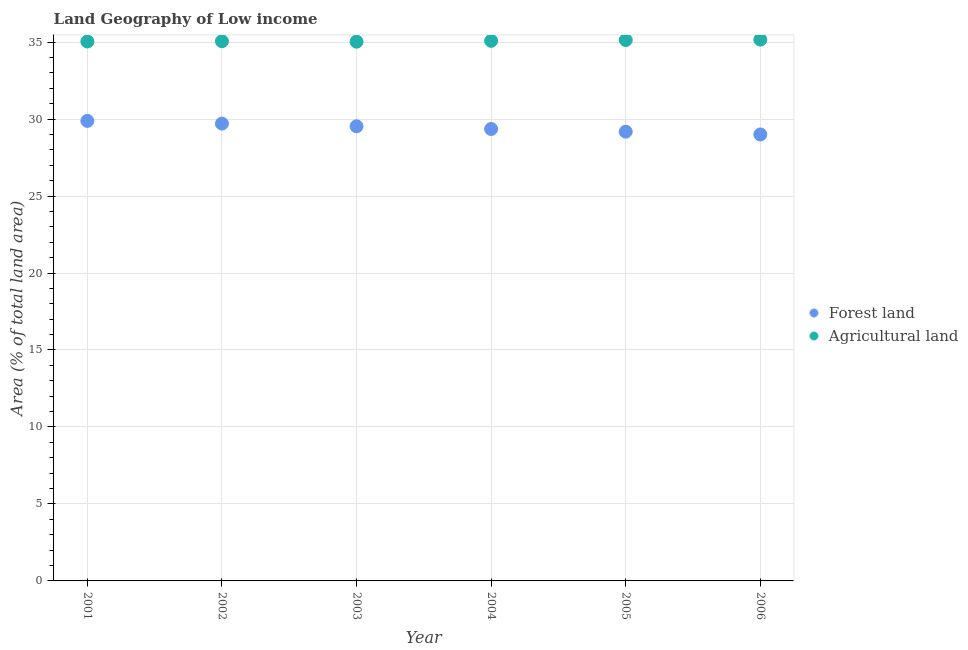Is the number of dotlines equal to the number of legend labels?
Provide a succinct answer. Yes. What is the percentage of land area under forests in 2001?
Ensure brevity in your answer.  29.88. Across all years, what is the maximum percentage of land area under forests?
Ensure brevity in your answer.  29.88. Across all years, what is the minimum percentage of land area under agriculture?
Keep it short and to the point. 35.03. In which year was the percentage of land area under agriculture minimum?
Give a very brief answer. 2003. What is the total percentage of land area under agriculture in the graph?
Keep it short and to the point. 210.5. What is the difference between the percentage of land area under forests in 2005 and that in 2006?
Give a very brief answer. 0.18. What is the difference between the percentage of land area under agriculture in 2001 and the percentage of land area under forests in 2004?
Your response must be concise. 5.68. What is the average percentage of land area under agriculture per year?
Make the answer very short. 35.08. In the year 2006, what is the difference between the percentage of land area under forests and percentage of land area under agriculture?
Give a very brief answer. -6.16. What is the ratio of the percentage of land area under agriculture in 2002 to that in 2006?
Give a very brief answer. 1. What is the difference between the highest and the second highest percentage of land area under forests?
Provide a short and direct response. 0.18. What is the difference between the highest and the lowest percentage of land area under agriculture?
Your response must be concise. 0.13. Does the percentage of land area under agriculture monotonically increase over the years?
Provide a succinct answer. No. Is the percentage of land area under forests strictly less than the percentage of land area under agriculture over the years?
Your answer should be compact. Yes. How many years are there in the graph?
Your response must be concise. 6. Are the values on the major ticks of Y-axis written in scientific E-notation?
Your answer should be very brief. No. Does the graph contain any zero values?
Your answer should be very brief. No. Does the graph contain grids?
Give a very brief answer. Yes. Where does the legend appear in the graph?
Keep it short and to the point. Center right. How many legend labels are there?
Provide a succinct answer. 2. How are the legend labels stacked?
Ensure brevity in your answer.  Vertical. What is the title of the graph?
Offer a terse response. Land Geography of Low income. What is the label or title of the X-axis?
Offer a terse response. Year. What is the label or title of the Y-axis?
Make the answer very short. Area (% of total land area). What is the Area (% of total land area) of Forest land in 2001?
Ensure brevity in your answer.  29.88. What is the Area (% of total land area) in Agricultural land in 2001?
Your answer should be compact. 35.04. What is the Area (% of total land area) in Forest land in 2002?
Ensure brevity in your answer.  29.71. What is the Area (% of total land area) of Agricultural land in 2002?
Make the answer very short. 35.06. What is the Area (% of total land area) in Forest land in 2003?
Provide a succinct answer. 29.53. What is the Area (% of total land area) of Agricultural land in 2003?
Ensure brevity in your answer.  35.03. What is the Area (% of total land area) of Forest land in 2004?
Your answer should be compact. 29.35. What is the Area (% of total land area) in Agricultural land in 2004?
Offer a terse response. 35.08. What is the Area (% of total land area) in Forest land in 2005?
Ensure brevity in your answer.  29.18. What is the Area (% of total land area) of Agricultural land in 2005?
Provide a short and direct response. 35.13. What is the Area (% of total land area) in Forest land in 2006?
Your answer should be very brief. 29. What is the Area (% of total land area) in Agricultural land in 2006?
Provide a short and direct response. 35.16. Across all years, what is the maximum Area (% of total land area) in Forest land?
Make the answer very short. 29.88. Across all years, what is the maximum Area (% of total land area) in Agricultural land?
Offer a terse response. 35.16. Across all years, what is the minimum Area (% of total land area) of Forest land?
Give a very brief answer. 29. Across all years, what is the minimum Area (% of total land area) in Agricultural land?
Ensure brevity in your answer.  35.03. What is the total Area (% of total land area) in Forest land in the graph?
Your answer should be compact. 176.65. What is the total Area (% of total land area) of Agricultural land in the graph?
Your answer should be compact. 210.5. What is the difference between the Area (% of total land area) of Forest land in 2001 and that in 2002?
Offer a terse response. 0.18. What is the difference between the Area (% of total land area) in Agricultural land in 2001 and that in 2002?
Give a very brief answer. -0.02. What is the difference between the Area (% of total land area) in Forest land in 2001 and that in 2003?
Give a very brief answer. 0.35. What is the difference between the Area (% of total land area) of Agricultural land in 2001 and that in 2003?
Your response must be concise. 0.01. What is the difference between the Area (% of total land area) of Forest land in 2001 and that in 2004?
Your answer should be compact. 0.53. What is the difference between the Area (% of total land area) of Agricultural land in 2001 and that in 2004?
Your answer should be compact. -0.04. What is the difference between the Area (% of total land area) in Forest land in 2001 and that in 2005?
Make the answer very short. 0.7. What is the difference between the Area (% of total land area) in Agricultural land in 2001 and that in 2005?
Your answer should be compact. -0.09. What is the difference between the Area (% of total land area) in Forest land in 2001 and that in 2006?
Ensure brevity in your answer.  0.88. What is the difference between the Area (% of total land area) of Agricultural land in 2001 and that in 2006?
Keep it short and to the point. -0.12. What is the difference between the Area (% of total land area) of Forest land in 2002 and that in 2003?
Keep it short and to the point. 0.18. What is the difference between the Area (% of total land area) in Agricultural land in 2002 and that in 2003?
Offer a terse response. 0.03. What is the difference between the Area (% of total land area) of Forest land in 2002 and that in 2004?
Ensure brevity in your answer.  0.35. What is the difference between the Area (% of total land area) in Agricultural land in 2002 and that in 2004?
Offer a very short reply. -0.02. What is the difference between the Area (% of total land area) of Forest land in 2002 and that in 2005?
Keep it short and to the point. 0.53. What is the difference between the Area (% of total land area) of Agricultural land in 2002 and that in 2005?
Your response must be concise. -0.07. What is the difference between the Area (% of total land area) in Forest land in 2002 and that in 2006?
Your answer should be compact. 0.71. What is the difference between the Area (% of total land area) in Agricultural land in 2002 and that in 2006?
Your answer should be compact. -0.1. What is the difference between the Area (% of total land area) in Forest land in 2003 and that in 2004?
Offer a terse response. 0.18. What is the difference between the Area (% of total land area) in Agricultural land in 2003 and that in 2004?
Give a very brief answer. -0.05. What is the difference between the Area (% of total land area) of Forest land in 2003 and that in 2005?
Provide a succinct answer. 0.35. What is the difference between the Area (% of total land area) of Agricultural land in 2003 and that in 2005?
Make the answer very short. -0.11. What is the difference between the Area (% of total land area) in Forest land in 2003 and that in 2006?
Give a very brief answer. 0.53. What is the difference between the Area (% of total land area) in Agricultural land in 2003 and that in 2006?
Offer a terse response. -0.13. What is the difference between the Area (% of total land area) in Forest land in 2004 and that in 2005?
Your answer should be very brief. 0.18. What is the difference between the Area (% of total land area) of Agricultural land in 2004 and that in 2005?
Ensure brevity in your answer.  -0.05. What is the difference between the Area (% of total land area) of Forest land in 2004 and that in 2006?
Your answer should be very brief. 0.35. What is the difference between the Area (% of total land area) in Agricultural land in 2004 and that in 2006?
Your answer should be very brief. -0.08. What is the difference between the Area (% of total land area) in Forest land in 2005 and that in 2006?
Give a very brief answer. 0.18. What is the difference between the Area (% of total land area) in Agricultural land in 2005 and that in 2006?
Make the answer very short. -0.03. What is the difference between the Area (% of total land area) of Forest land in 2001 and the Area (% of total land area) of Agricultural land in 2002?
Keep it short and to the point. -5.18. What is the difference between the Area (% of total land area) of Forest land in 2001 and the Area (% of total land area) of Agricultural land in 2003?
Offer a very short reply. -5.15. What is the difference between the Area (% of total land area) of Forest land in 2001 and the Area (% of total land area) of Agricultural land in 2005?
Your answer should be very brief. -5.25. What is the difference between the Area (% of total land area) of Forest land in 2001 and the Area (% of total land area) of Agricultural land in 2006?
Give a very brief answer. -5.28. What is the difference between the Area (% of total land area) of Forest land in 2002 and the Area (% of total land area) of Agricultural land in 2003?
Keep it short and to the point. -5.32. What is the difference between the Area (% of total land area) in Forest land in 2002 and the Area (% of total land area) in Agricultural land in 2004?
Your answer should be very brief. -5.38. What is the difference between the Area (% of total land area) in Forest land in 2002 and the Area (% of total land area) in Agricultural land in 2005?
Give a very brief answer. -5.43. What is the difference between the Area (% of total land area) in Forest land in 2002 and the Area (% of total land area) in Agricultural land in 2006?
Provide a succinct answer. -5.45. What is the difference between the Area (% of total land area) of Forest land in 2003 and the Area (% of total land area) of Agricultural land in 2004?
Your answer should be very brief. -5.55. What is the difference between the Area (% of total land area) in Forest land in 2003 and the Area (% of total land area) in Agricultural land in 2005?
Your response must be concise. -5.6. What is the difference between the Area (% of total land area) of Forest land in 2003 and the Area (% of total land area) of Agricultural land in 2006?
Offer a terse response. -5.63. What is the difference between the Area (% of total land area) in Forest land in 2004 and the Area (% of total land area) in Agricultural land in 2005?
Ensure brevity in your answer.  -5.78. What is the difference between the Area (% of total land area) of Forest land in 2004 and the Area (% of total land area) of Agricultural land in 2006?
Your answer should be very brief. -5.81. What is the difference between the Area (% of total land area) in Forest land in 2005 and the Area (% of total land area) in Agricultural land in 2006?
Keep it short and to the point. -5.98. What is the average Area (% of total land area) of Forest land per year?
Give a very brief answer. 29.44. What is the average Area (% of total land area) of Agricultural land per year?
Offer a terse response. 35.08. In the year 2001, what is the difference between the Area (% of total land area) in Forest land and Area (% of total land area) in Agricultural land?
Give a very brief answer. -5.16. In the year 2002, what is the difference between the Area (% of total land area) of Forest land and Area (% of total land area) of Agricultural land?
Ensure brevity in your answer.  -5.35. In the year 2003, what is the difference between the Area (% of total land area) of Forest land and Area (% of total land area) of Agricultural land?
Offer a very short reply. -5.5. In the year 2004, what is the difference between the Area (% of total land area) in Forest land and Area (% of total land area) in Agricultural land?
Offer a terse response. -5.73. In the year 2005, what is the difference between the Area (% of total land area) in Forest land and Area (% of total land area) in Agricultural land?
Your answer should be very brief. -5.95. In the year 2006, what is the difference between the Area (% of total land area) of Forest land and Area (% of total land area) of Agricultural land?
Offer a terse response. -6.16. What is the ratio of the Area (% of total land area) in Forest land in 2001 to that in 2002?
Keep it short and to the point. 1.01. What is the ratio of the Area (% of total land area) in Agricultural land in 2001 to that in 2002?
Provide a short and direct response. 1. What is the ratio of the Area (% of total land area) of Forest land in 2001 to that in 2003?
Offer a terse response. 1.01. What is the ratio of the Area (% of total land area) in Forest land in 2001 to that in 2004?
Ensure brevity in your answer.  1.02. What is the ratio of the Area (% of total land area) of Forest land in 2001 to that in 2005?
Offer a very short reply. 1.02. What is the ratio of the Area (% of total land area) in Forest land in 2001 to that in 2006?
Offer a terse response. 1.03. What is the ratio of the Area (% of total land area) in Agricultural land in 2001 to that in 2006?
Give a very brief answer. 1. What is the ratio of the Area (% of total land area) of Forest land in 2002 to that in 2003?
Your response must be concise. 1.01. What is the ratio of the Area (% of total land area) in Agricultural land in 2002 to that in 2003?
Your response must be concise. 1. What is the ratio of the Area (% of total land area) in Forest land in 2002 to that in 2004?
Your answer should be compact. 1.01. What is the ratio of the Area (% of total land area) in Agricultural land in 2002 to that in 2004?
Keep it short and to the point. 1. What is the ratio of the Area (% of total land area) in Forest land in 2002 to that in 2005?
Your answer should be compact. 1.02. What is the ratio of the Area (% of total land area) in Agricultural land in 2002 to that in 2005?
Provide a succinct answer. 1. What is the ratio of the Area (% of total land area) in Forest land in 2002 to that in 2006?
Make the answer very short. 1.02. What is the ratio of the Area (% of total land area) of Agricultural land in 2002 to that in 2006?
Make the answer very short. 1. What is the ratio of the Area (% of total land area) of Forest land in 2003 to that in 2004?
Provide a succinct answer. 1.01. What is the ratio of the Area (% of total land area) of Agricultural land in 2003 to that in 2005?
Your answer should be very brief. 1. What is the ratio of the Area (% of total land area) in Forest land in 2003 to that in 2006?
Make the answer very short. 1.02. What is the ratio of the Area (% of total land area) in Agricultural land in 2003 to that in 2006?
Your answer should be very brief. 1. What is the ratio of the Area (% of total land area) in Forest land in 2004 to that in 2005?
Your answer should be compact. 1.01. What is the ratio of the Area (% of total land area) of Forest land in 2004 to that in 2006?
Make the answer very short. 1.01. What is the ratio of the Area (% of total land area) in Forest land in 2005 to that in 2006?
Provide a short and direct response. 1.01. What is the ratio of the Area (% of total land area) in Agricultural land in 2005 to that in 2006?
Your answer should be very brief. 1. What is the difference between the highest and the second highest Area (% of total land area) in Forest land?
Offer a terse response. 0.18. What is the difference between the highest and the second highest Area (% of total land area) of Agricultural land?
Provide a succinct answer. 0.03. What is the difference between the highest and the lowest Area (% of total land area) of Forest land?
Offer a terse response. 0.88. What is the difference between the highest and the lowest Area (% of total land area) of Agricultural land?
Offer a terse response. 0.13. 